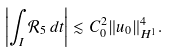Convert formula to latex. <formula><loc_0><loc_0><loc_500><loc_500>\left | \int _ { I } \mathcal { R } _ { 5 } \, d t \right | \lesssim C _ { 0 } ^ { 2 } \| u _ { 0 } \| _ { H ^ { 1 } } ^ { 4 } .</formula> 